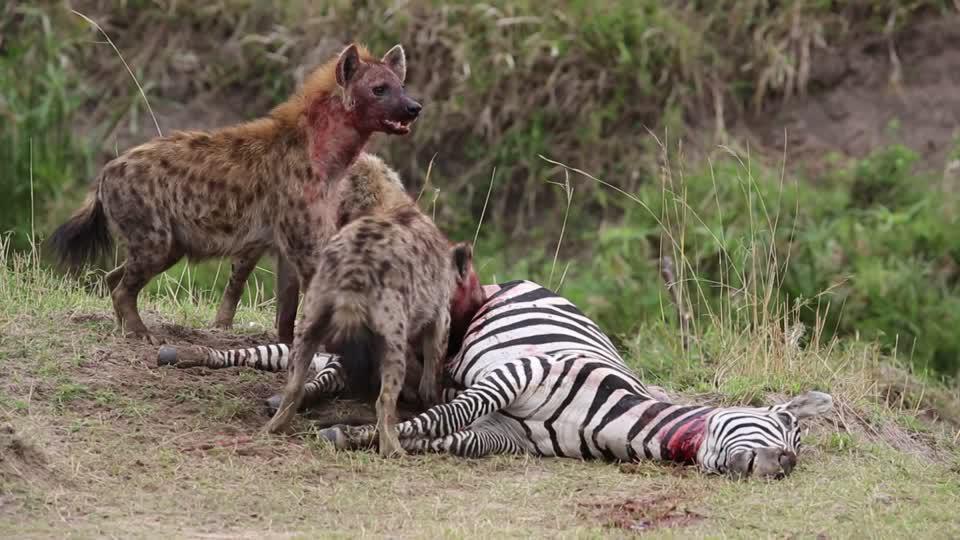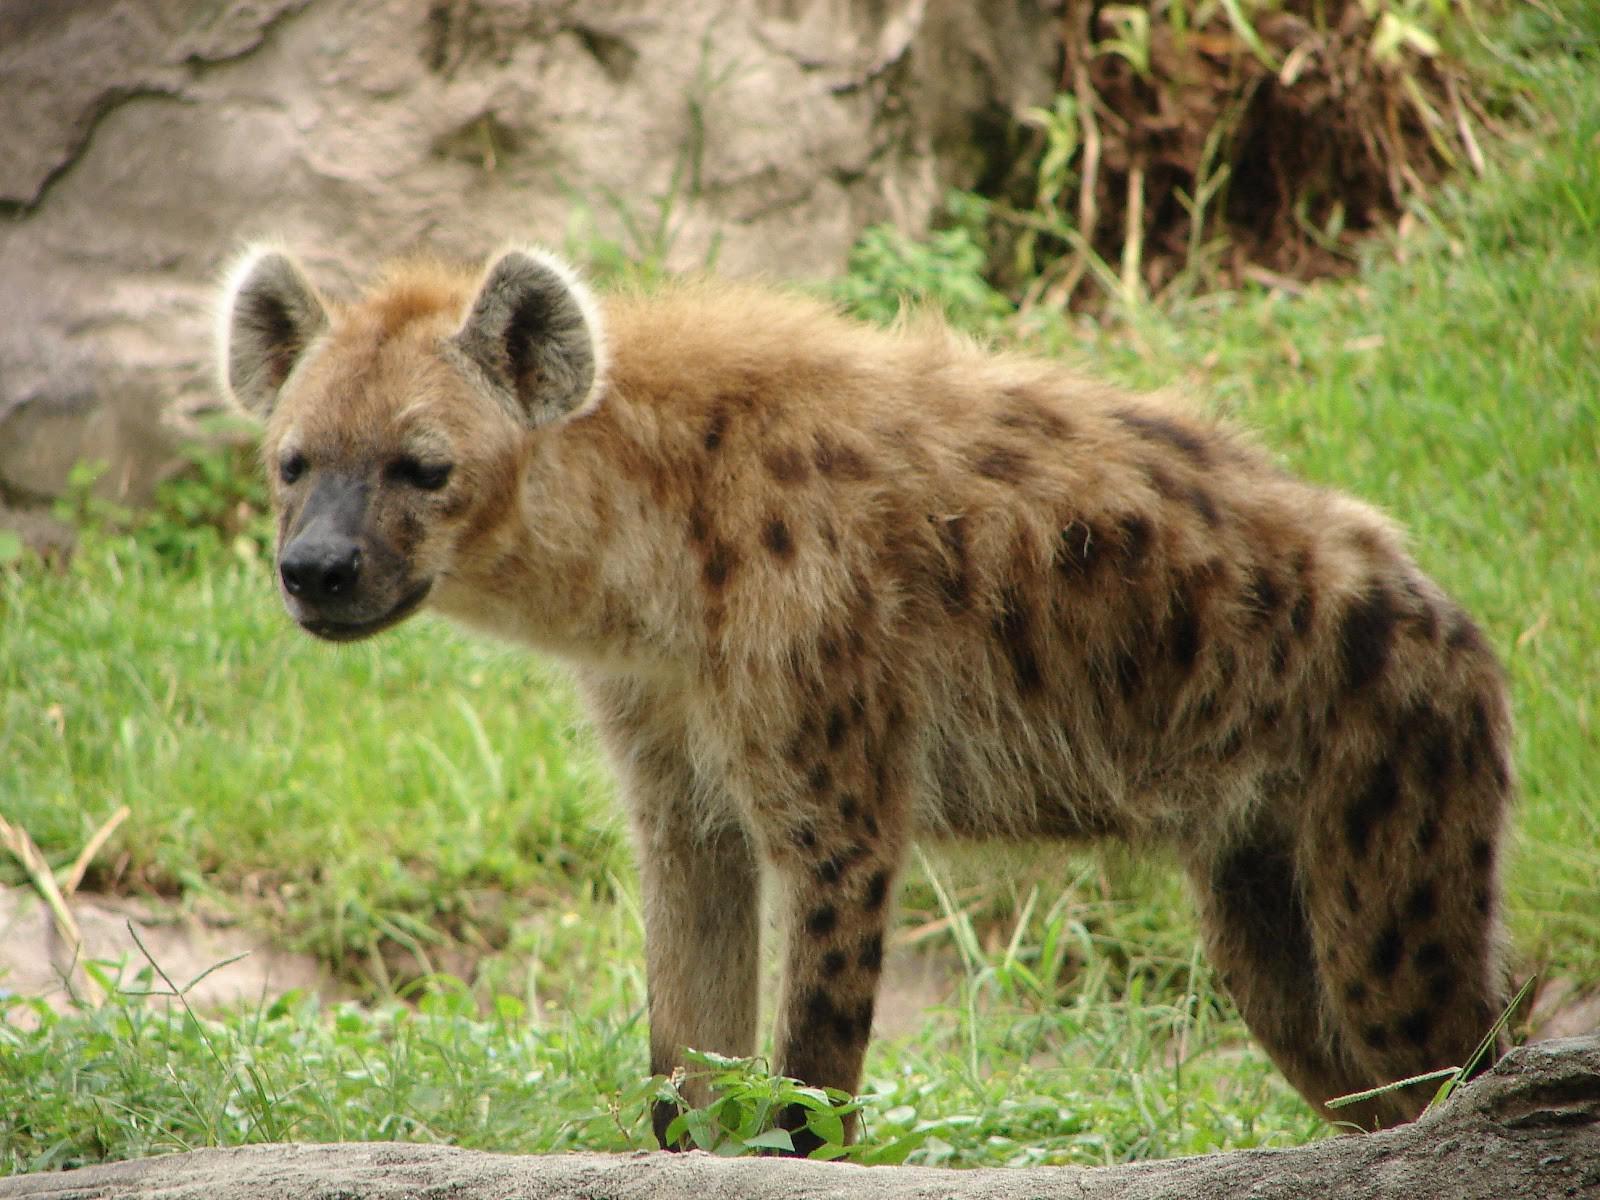The first image is the image on the left, the second image is the image on the right. Assess this claim about the two images: "There are two hyenas in a photo.". Correct or not? Answer yes or no. Yes. 